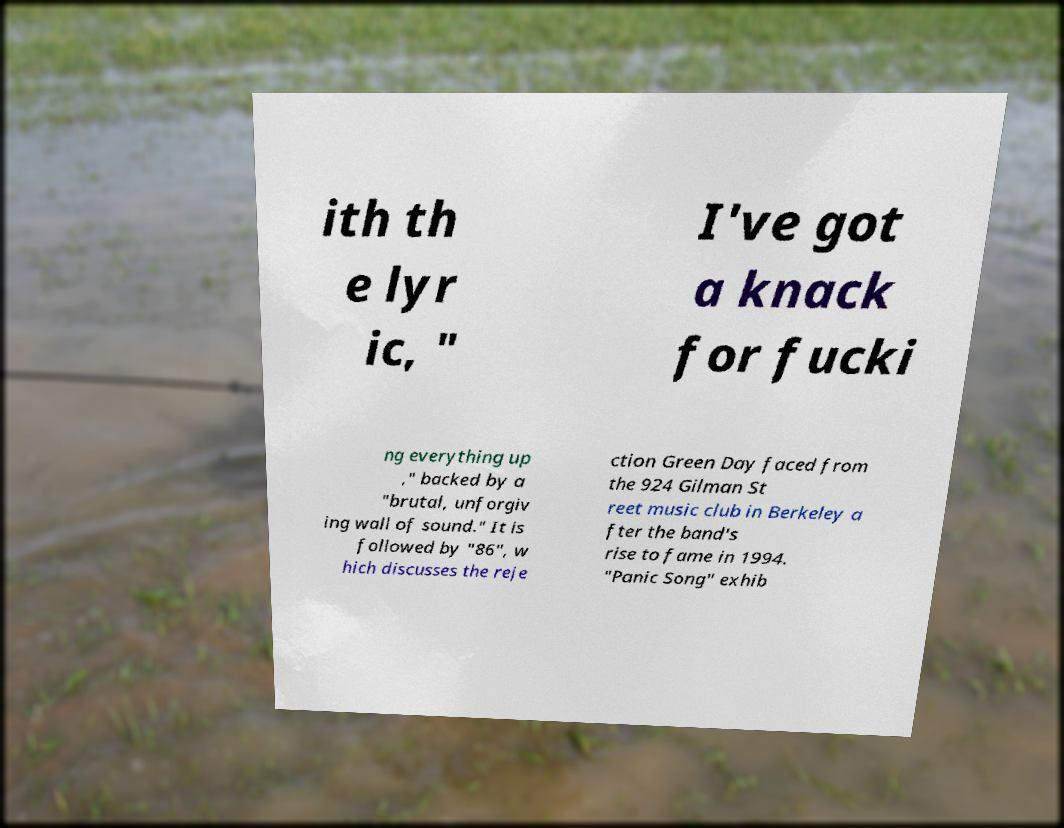For documentation purposes, I need the text within this image transcribed. Could you provide that? ith th e lyr ic, " I've got a knack for fucki ng everything up ," backed by a "brutal, unforgiv ing wall of sound." It is followed by "86", w hich discusses the reje ction Green Day faced from the 924 Gilman St reet music club in Berkeley a fter the band's rise to fame in 1994. "Panic Song" exhib 